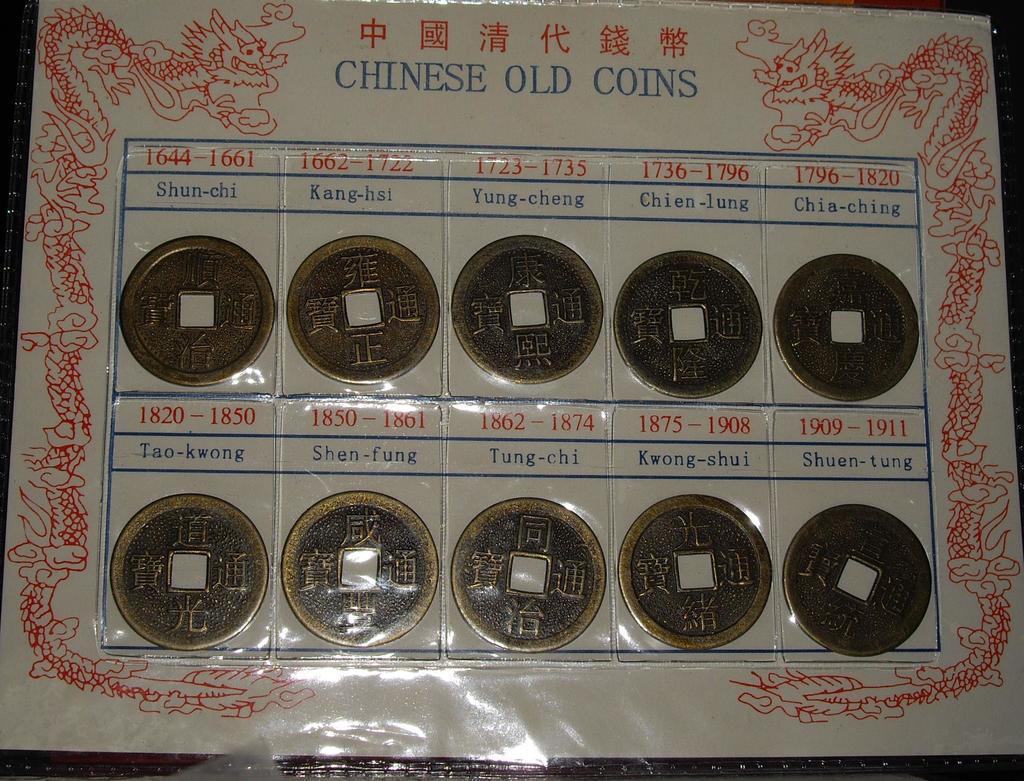<image>
Present a compact description of the photo's key features. Many coins inside some plastic with words that say "Chinese Old Coins" on the top. 